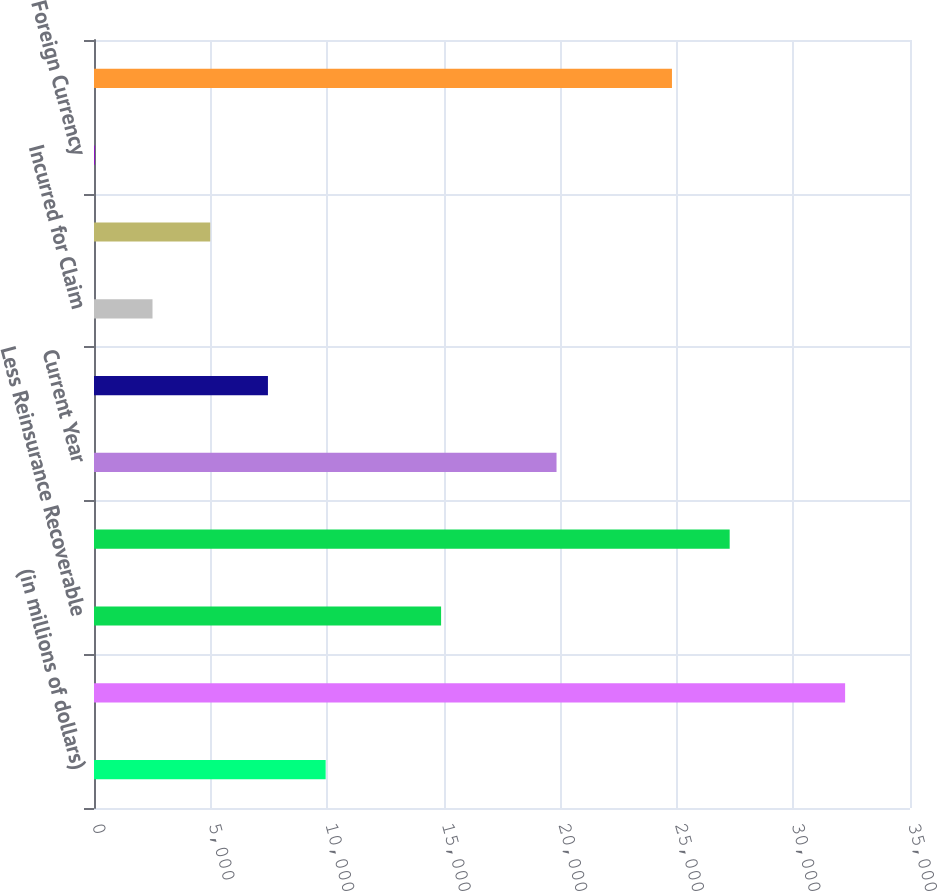Convert chart. <chart><loc_0><loc_0><loc_500><loc_500><bar_chart><fcel>(in millions of dollars)<fcel>Balance at January 1<fcel>Less Reinsurance Recoverable<fcel>Net Balance at January 1<fcel>Current Year<fcel>Interest<fcel>Incurred for Claim<fcel>All Other Incurred<fcel>Foreign Currency<fcel>Total Incurred<nl><fcel>9936.22<fcel>32216.9<fcel>14887.5<fcel>27265.6<fcel>19838.7<fcel>7460.59<fcel>2509.33<fcel>4984.96<fcel>33.7<fcel>24790<nl></chart> 